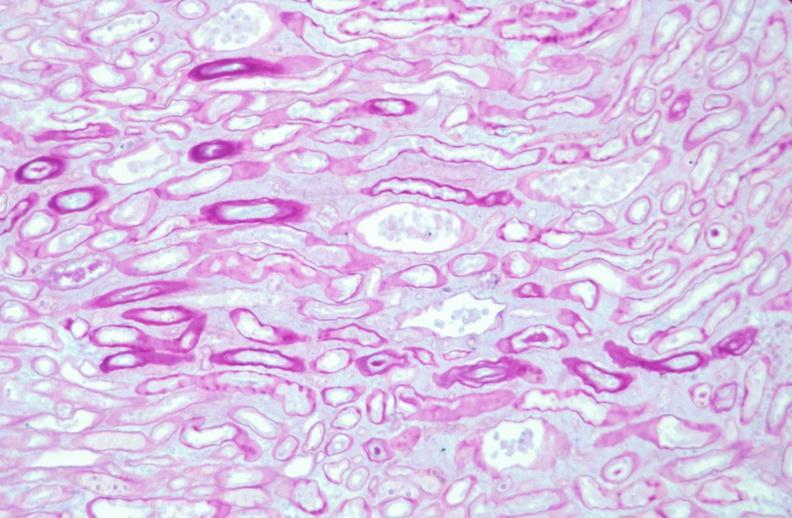does this image show kidney, thickened and hyalinized basement membranes due to diabetes mellitus, pas?
Answer the question using a single word or phrase. Yes 